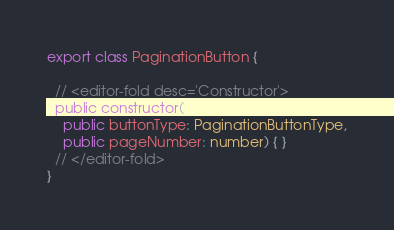Convert code to text. <code><loc_0><loc_0><loc_500><loc_500><_TypeScript_>
export class PaginationButton {

  // <editor-fold desc='Constructor'>
  public constructor(
    public buttonType: PaginationButtonType,
    public pageNumber: number) { }
  // </editor-fold>
}
</code> 